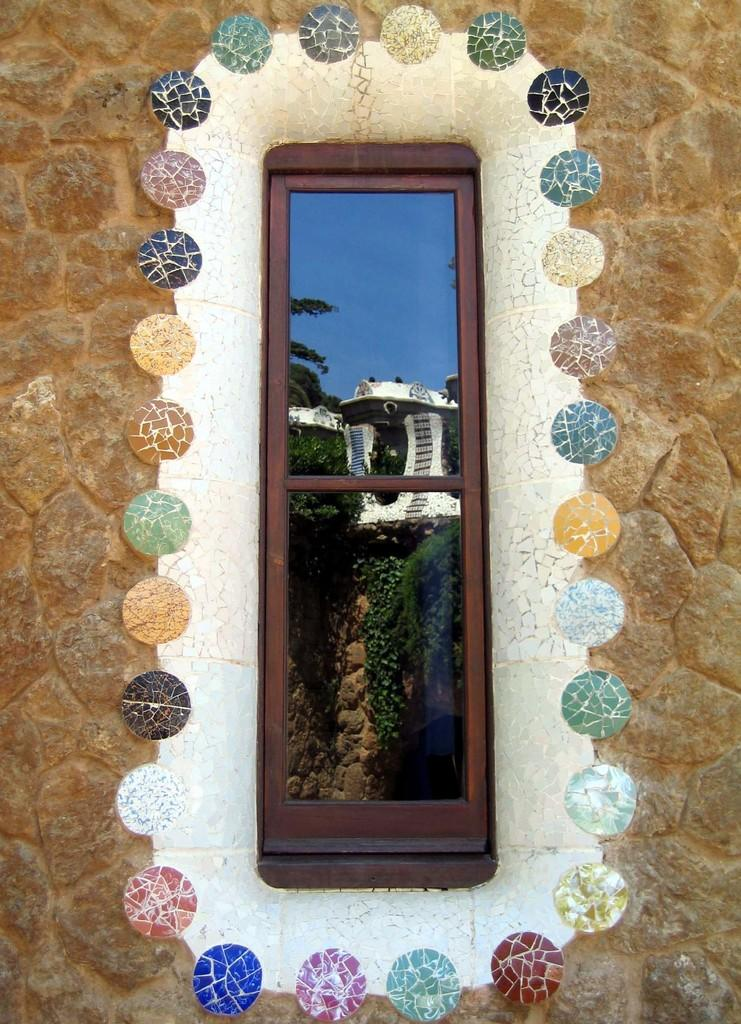What type of structure is present in the image? There is a brick wall in the image. What feature can be seen on the brick wall? There is a window on the brick wall. What can be observed around the window? There are stones of different colors around the window. What is visible through the window? Trees and the sky are visible through the window, as well as a white-colored building. What type of apparel is the ladybug wearing in the image? There is no ladybug present in the image, so it is not possible to determine what apparel it might be wearing. 